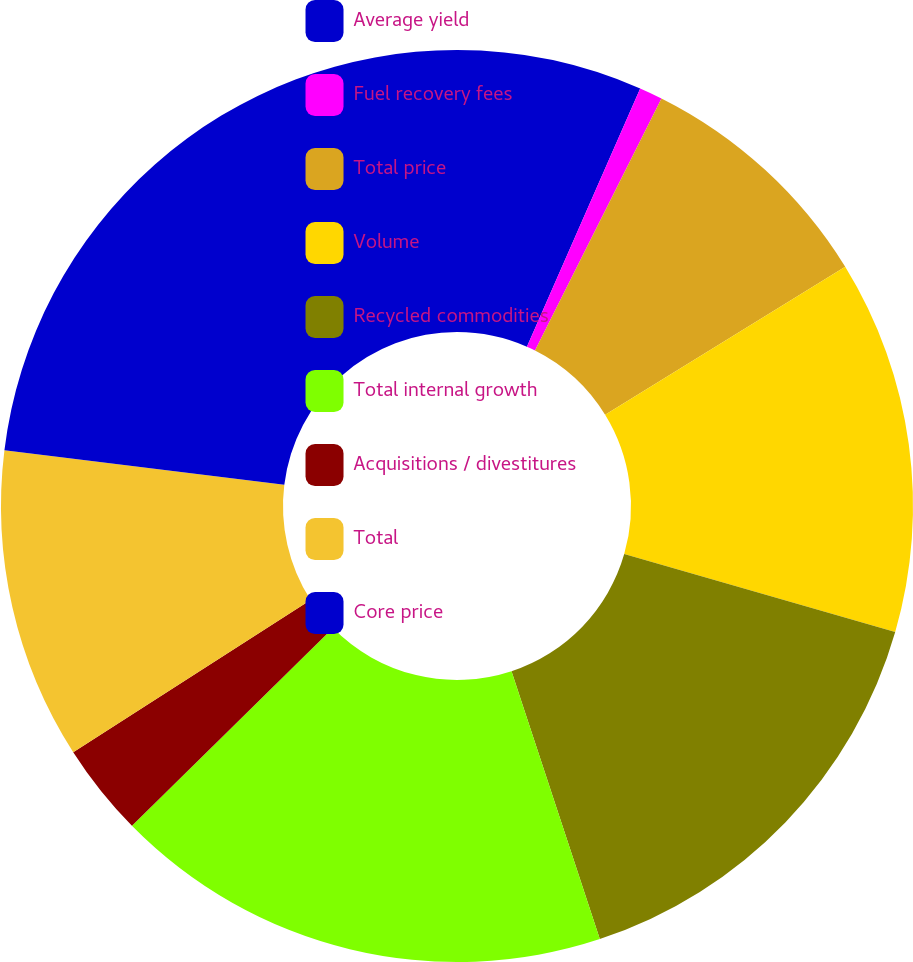Convert chart. <chart><loc_0><loc_0><loc_500><loc_500><pie_chart><fcel>Average yield<fcel>Fuel recovery fees<fcel>Total price<fcel>Volume<fcel>Recycled commodities<fcel>Total internal growth<fcel>Acquisitions / divestitures<fcel>Total<fcel>Core price<nl><fcel>6.58%<fcel>0.82%<fcel>8.81%<fcel>13.25%<fcel>15.47%<fcel>17.7%<fcel>3.29%<fcel>11.03%<fcel>23.05%<nl></chart> 